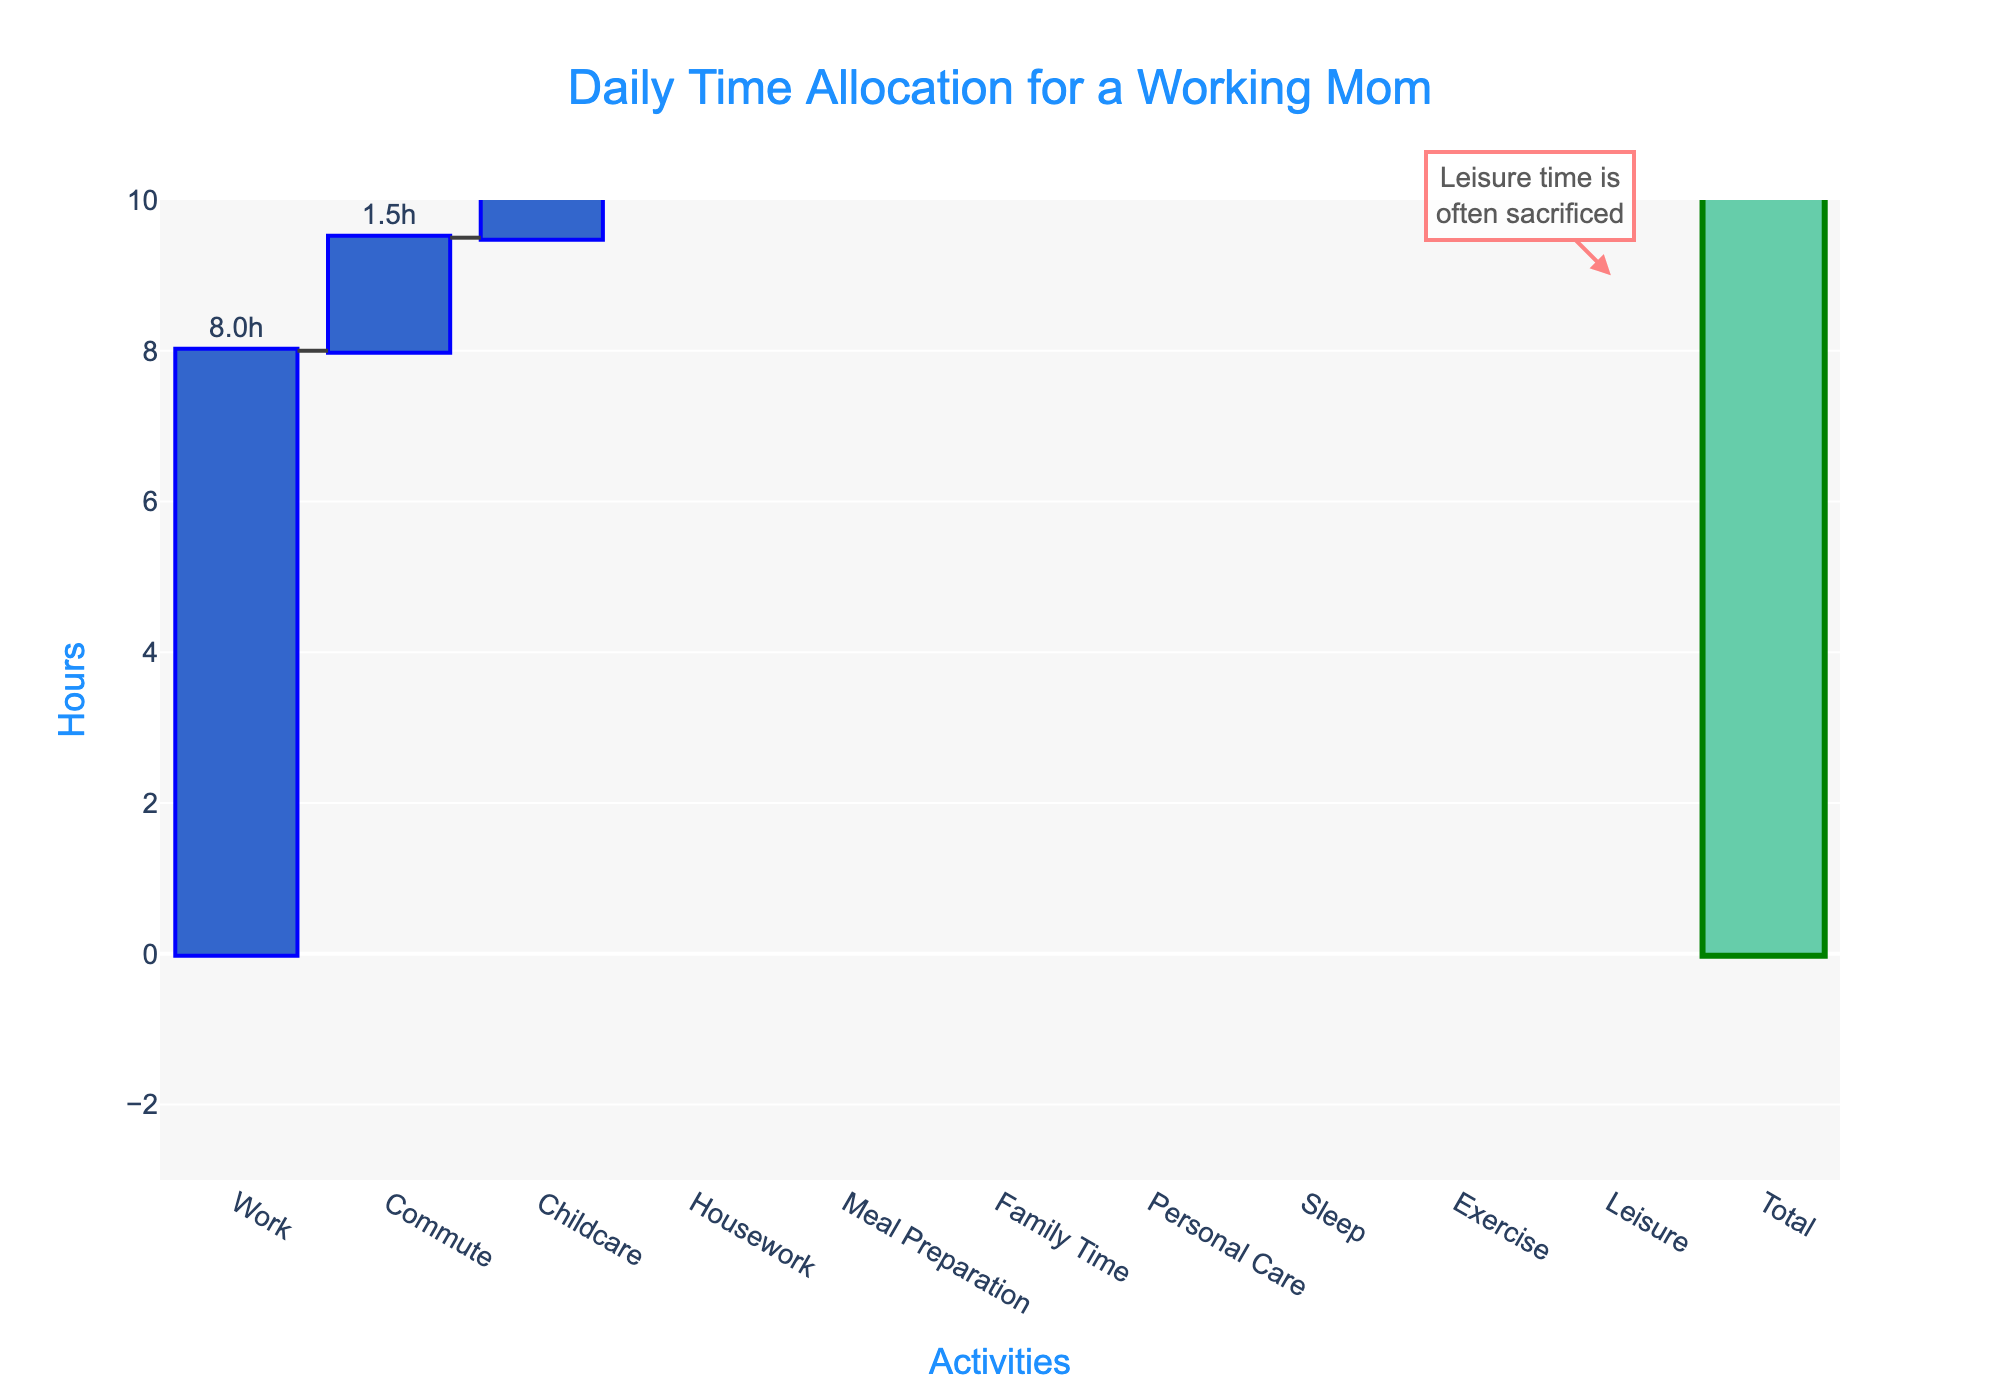what is the title of the Chart? The title is often located at the top of the chart. Here, it states, "Daily Time Allocation for a Working Mom"
Answer: Daily Time Allocation for a Working Mom What category takes up the most time in the chart? By looking at the tallest bar in the chart, we can see that "Work" has the highest value of 8 hours.
Answer: Work How much time is spent on childcare and housework combined? Childcare takes 3 hours and housework takes 2 hours. Adding these together: 3 + 2 = 5 hours.
Answer: 5 hours Which activity has its time represented as a negative value and how much is it? Leisure is represented as a negative value, and the amount is -2 hours.
Answer: Leisure, -2 hours What is the total amount of time allocated across all activities? The total amount is indicated by the bar labeled "Total" and it's 24 hours.
Answer: 24 hours How does sleep time compare to work time in the chart? Sleep takes 7 hours, while work takes 8 hours. Therefore, work takes 1 more hour than sleep.
Answer: Work takes 1 more hour How much time is allocated for exercise? Exercise is represented as a small bar labeled "Exercise" with a value of 0.5 hours.
Answer: 0.5 hours If you add the time for personal care and meal preparation, what is the total? Personal care takes 1 hour and meal preparation also takes 1 hour. Adding these together: 1 + 1 = 2 hours.
Answer: 2 hours What does the annotation in the graph indicate about leisure time? The annotation says, "Leisure time is often sacrificed" pointing out that leisure time is reduced or given a negative value.
Answer: Leisure time is often sacrificed 